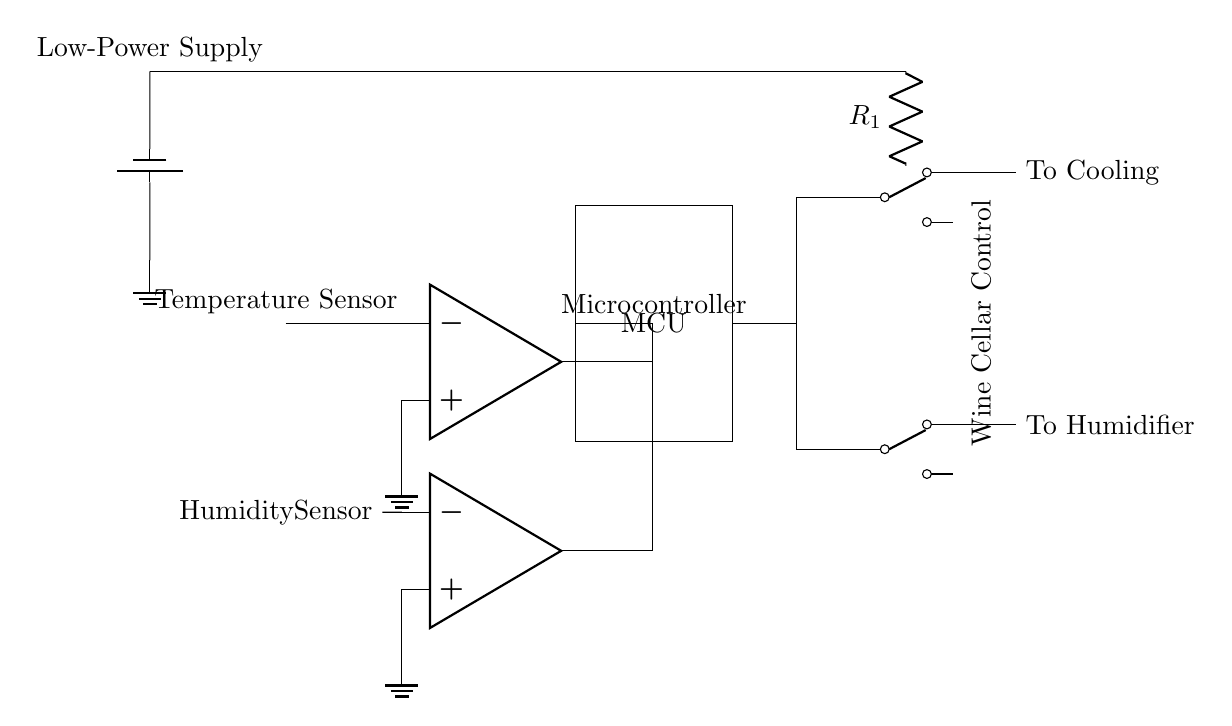What is the primary function of the temperature sensor? The primary function is to measure the temperature within the wine cellar, providing essential data for controlling the environment.
Answer: Measure temperature What type of component is used for humidity sensing? The component labeled as "Humidity Sensor" identifies the technology used for measuring moisture levels in the air.
Answer: Humidity Sensor How is the microcontroller powered in this circuit? The microcontroller receives power from the battery connected at the top left of the circuit diagram, supplying voltage for operation.
Answer: Battery What does the relay labeled "To Cooling" control? The relay is responsible for activating or deactivating the cooling mechanism based on signals from the microcontroller, which processes inputs from the temperature sensor.
Answer: Cooling mechanism How many op-amps are utilized in this circuit? There are two operational amplifiers in the circuit, each connected to a different sensor to process their respective signals.
Answer: Two Which component connects the temperature and humidity sensors to the microcontroller? The outputs from both sensors are routed to the microcontroller via wires, allowing it to receive data for processing.
Answer: Wires What is the low-power supply voltage indicated in the circuit? The circuit uses a battery supply and though the voltage isn't specified, it typically suggests a low-voltage range suitable for low-power applications. The common supply would be 5V for similar circuits.
Answer: Low voltage (typically 5V) 